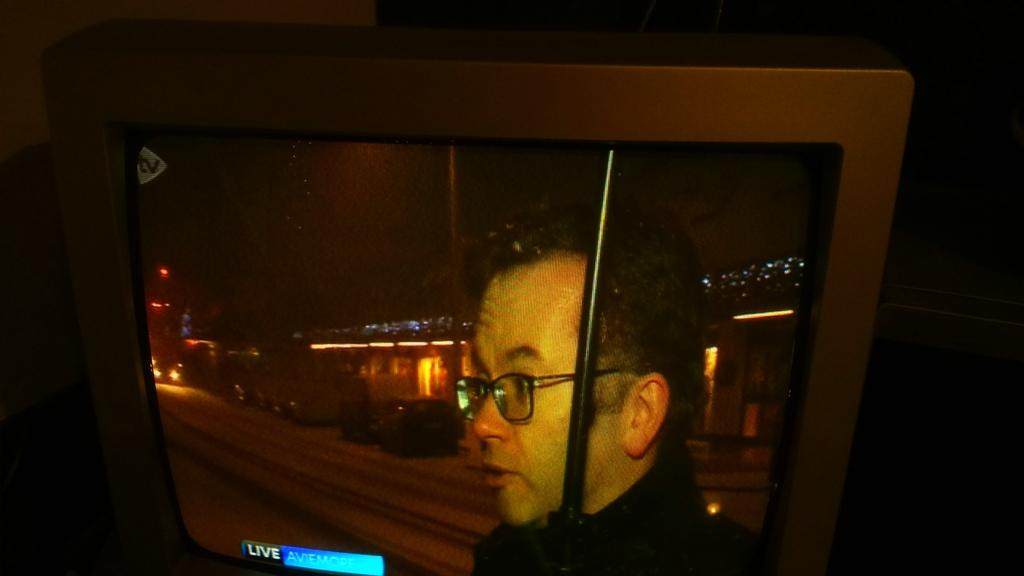What is the main object in the image? There is a computer screen in the image. Who is present in the image? A man is standing in front of the computer screen. What is the man doing in the image? The man is looking to the left. What can be seen in the background of the image? There is a view of the city in the background of the image. What is a notable feature of the city view? The city view includes lights. How many pigs are visible in the image? There are no pigs present in the image. Where is the birth of the man in the image taking place? The image does not show or imply any information about the man's birth. 